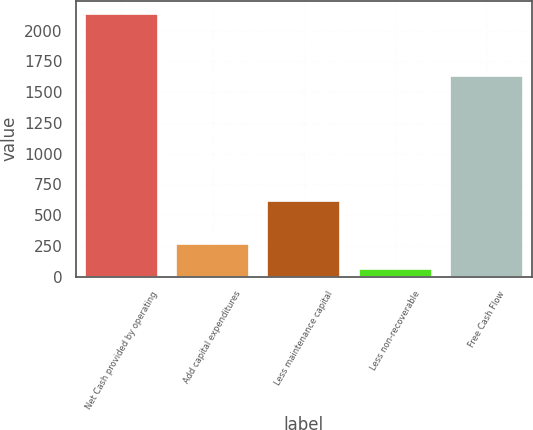Convert chart. <chart><loc_0><loc_0><loc_500><loc_500><bar_chart><fcel>Net Cash provided by operating<fcel>Add capital expenditures<fcel>Less maintenance capital<fcel>Less non-recoverable<fcel>Free Cash Flow<nl><fcel>2134<fcel>267.4<fcel>611<fcel>60<fcel>1628<nl></chart> 